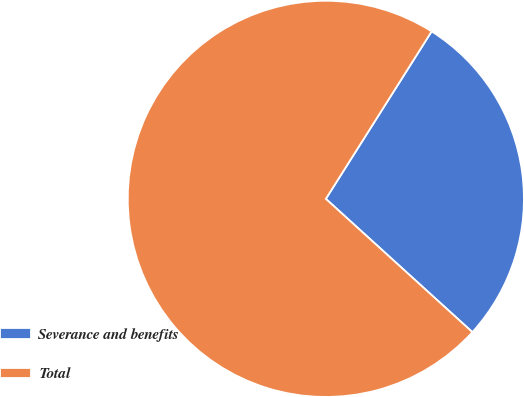Convert chart to OTSL. <chart><loc_0><loc_0><loc_500><loc_500><pie_chart><fcel>Severance and benefits<fcel>Total<nl><fcel>27.78%<fcel>72.22%<nl></chart> 